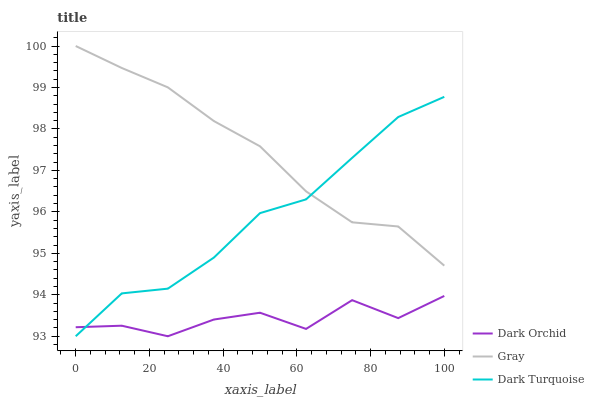Does Dark Orchid have the minimum area under the curve?
Answer yes or no. Yes. Does Gray have the maximum area under the curve?
Answer yes or no. Yes. Does Dark Turquoise have the minimum area under the curve?
Answer yes or no. No. Does Dark Turquoise have the maximum area under the curve?
Answer yes or no. No. Is Gray the smoothest?
Answer yes or no. Yes. Is Dark Orchid the roughest?
Answer yes or no. Yes. Is Dark Turquoise the smoothest?
Answer yes or no. No. Is Dark Turquoise the roughest?
Answer yes or no. No. Does Dark Orchid have the lowest value?
Answer yes or no. Yes. Does Gray have the highest value?
Answer yes or no. Yes. Does Dark Turquoise have the highest value?
Answer yes or no. No. Is Dark Orchid less than Gray?
Answer yes or no. Yes. Is Gray greater than Dark Orchid?
Answer yes or no. Yes. Does Dark Turquoise intersect Gray?
Answer yes or no. Yes. Is Dark Turquoise less than Gray?
Answer yes or no. No. Is Dark Turquoise greater than Gray?
Answer yes or no. No. Does Dark Orchid intersect Gray?
Answer yes or no. No. 